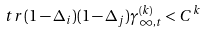<formula> <loc_0><loc_0><loc_500><loc_500>\ t r \, ( 1 - \Delta _ { i } ) ( 1 - \Delta _ { j } ) \gamma ^ { ( k ) } _ { \infty , t } < C ^ { k }</formula> 